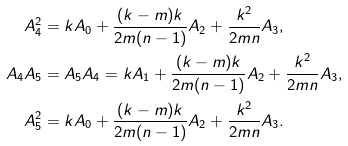Convert formula to latex. <formula><loc_0><loc_0><loc_500><loc_500>A _ { 4 } ^ { 2 } & = k A _ { 0 } + \frac { ( k - m ) k } { 2 m ( n - 1 ) } A _ { 2 } + \frac { k ^ { 2 } } { 2 m n } A _ { 3 } , \\ A _ { 4 } A _ { 5 } & = A _ { 5 } A _ { 4 } = k A _ { 1 } + \frac { ( k - m ) k } { 2 m ( n - 1 ) } A _ { 2 } + \frac { k ^ { 2 } } { 2 m n } A _ { 3 } , \\ A _ { 5 } ^ { 2 } & = k A _ { 0 } + \frac { ( k - m ) k } { 2 m ( n - 1 ) } A _ { 2 } + \frac { k ^ { 2 } } { 2 m n } A _ { 3 } .</formula> 